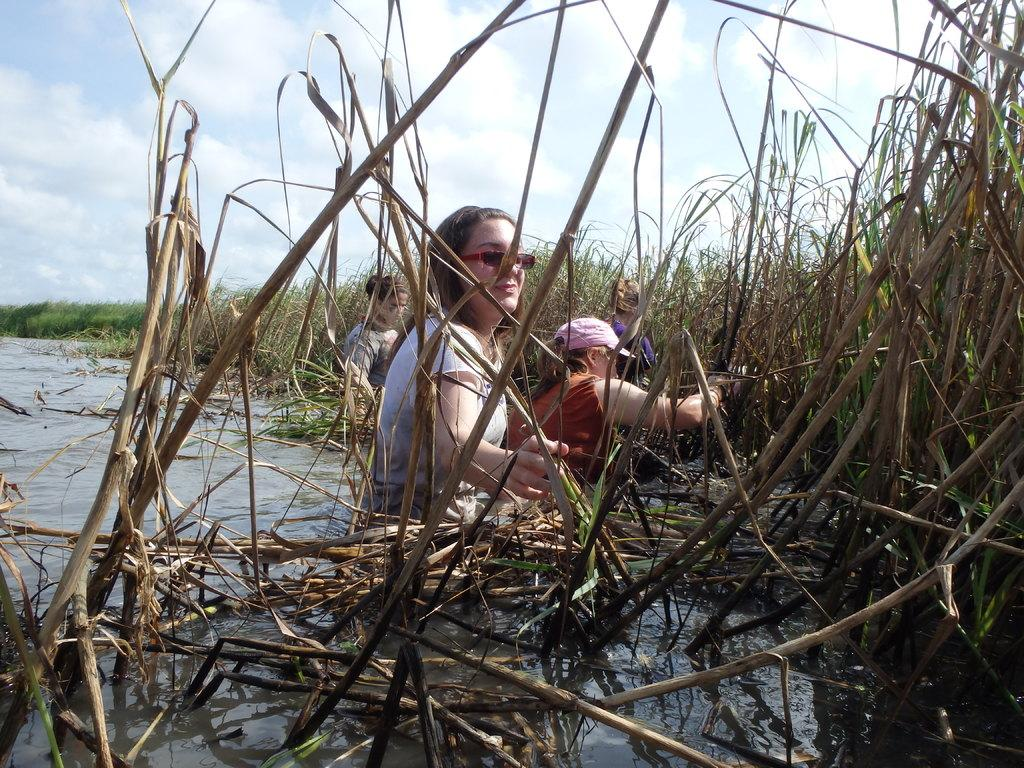What are the persons in the image doing? The persons in the image are partially in the water. What can be seen in the background of the image? There is grass, plants, and clouds in the sky visible in the background of the image. Reasoning: Let's think step by step by step in order to produce the conversation. We start by identifying the main subjects in the image, which are the persons partially in the water. Then, we expand the conversation to include other elements visible in the background, such as grass, plants, and clouds. Each question is designed to elicit a specific detail about the image that is known from the provided facts. Absurd Question/Answer: How many bikes are parked near the hole in the image? There is no hole or bikes present in the image. 